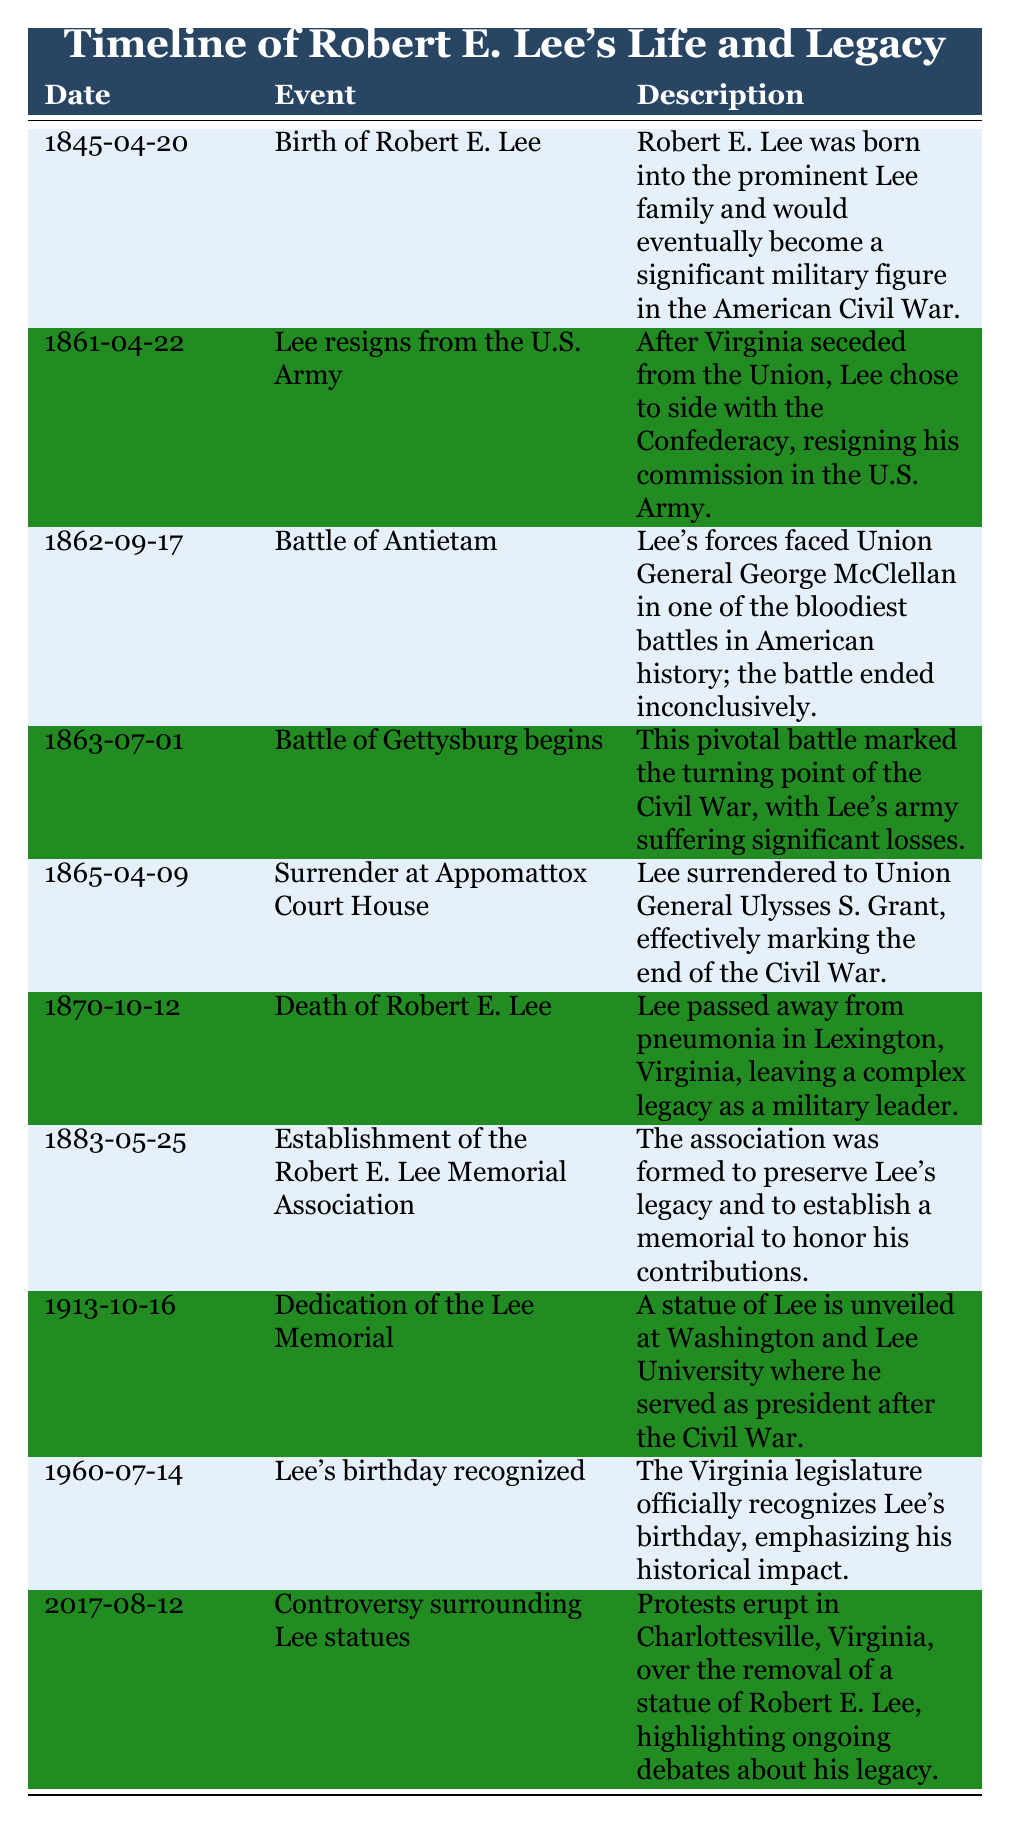What date did Robert E. Lee resign from the U.S. Army? The table lists the event "Lee resigns from the U.S. Army" dated "1861-04-22."
Answer: 1861-04-22 What event occurred on April 9, 1865? By examining the table, on April 9, 1865, the event noted is "Surrender at Appomattox Court House."
Answer: Surrender at Appomattox Court House How many years did Robert E. Lee live? Lee was born on April 20, 1845, and died on October 12, 1870. The difference between these dates is 1870 - 1845 = 25 years, but since he died after his birthday, it's 25 years.
Answer: 25 years What significant battle took place on September 17, 1862? According to the table, the "Battle of Antietam" occurred on September 17, 1862.
Answer: Battle of Antietam What major event ended on April 9, 1865? The table indicates that Lee's surrender on this date marked the end of the Civil War.
Answer: End of the Civil War Did Robert E. Lee's birthday receive official recognition by any legislature? The table states that "Lee’s birthday recognized by Virginia state legislature" on July 14, 1960, confirming it.
Answer: Yes What was the last event listed in the timeline? The final event in the table is "Controversy surrounding Lee statues," dated August 12, 2017.
Answer: Controversy surrounding Lee statues Which battle is noted as the turning point of the Civil War? The table specifies "Battle of Gettysburg begins," dated July 1, 1863, as the turning point of the Civil War.
Answer: Battle of Gettysburg How many years passed between Robert E. Lee's birth and his death? Lee was born on April 20, 1845, and died on October 12, 1870. Thus, from 1845 to 1870 is 25 years.
Answer: 25 years In what year was the statue of Robert E. Lee unveiled at Washington and Lee University? The event "Dedication of the Lee Memorial" occurred on October 16, 1913.
Answer: 1913 What were the two significant battles Lee was involved in during the Civil War according to the table? The table shows "Battle of Antietam" and "Battle of Gettysburg" as significant battles involving Lee during the Civil War.
Answer: Battle of Antietam and Battle of Gettysburg Was there an event recognizing Lee's contributions prior to his death? Yes, the establishment of the Robert E. Lee Memorial Association occurred on May 25, 1883, which is before Lee's death in 1870, indicating contributions were recognized posthumously.
Answer: Yes How does the event on August 12, 2017, relate to the legacy of Robert E. Lee? The event "Controversy surrounding Lee statues" highlights ongoing debates about his legacy, showcasing differing views on how he is remembered today, indicating a continuing impact of his life and actions.
Answer: Ongoing debates about his legacy 